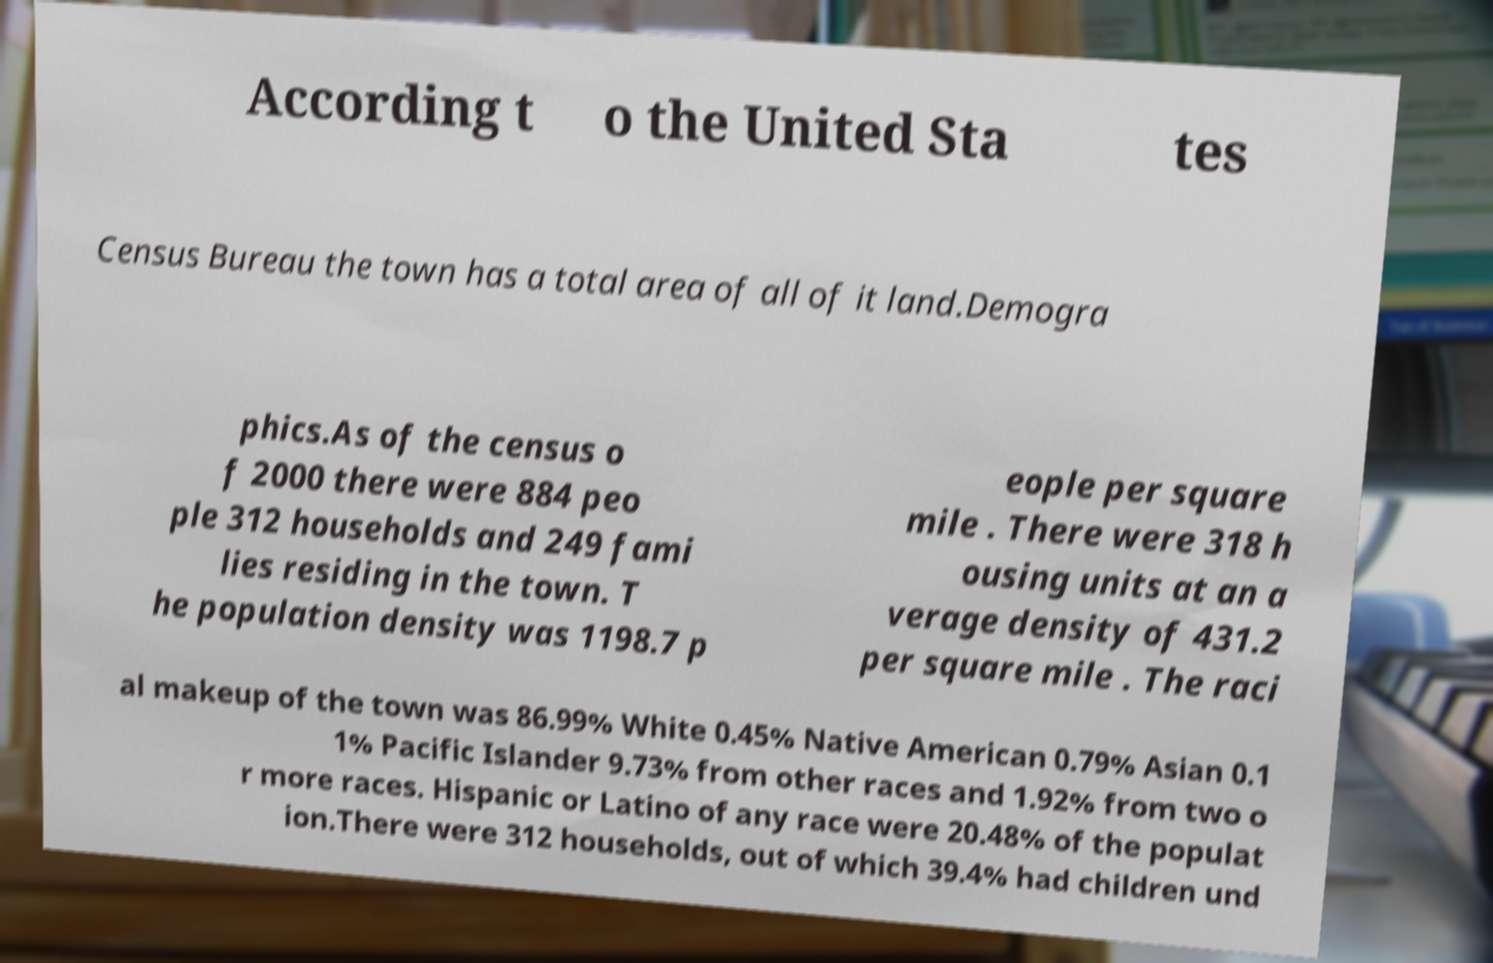What messages or text are displayed in this image? I need them in a readable, typed format. According t o the United Sta tes Census Bureau the town has a total area of all of it land.Demogra phics.As of the census o f 2000 there were 884 peo ple 312 households and 249 fami lies residing in the town. T he population density was 1198.7 p eople per square mile . There were 318 h ousing units at an a verage density of 431.2 per square mile . The raci al makeup of the town was 86.99% White 0.45% Native American 0.79% Asian 0.1 1% Pacific Islander 9.73% from other races and 1.92% from two o r more races. Hispanic or Latino of any race were 20.48% of the populat ion.There were 312 households, out of which 39.4% had children und 